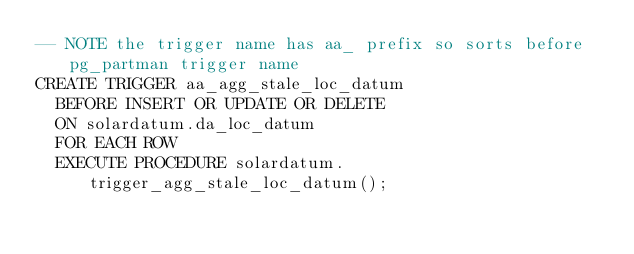Convert code to text. <code><loc_0><loc_0><loc_500><loc_500><_SQL_>-- NOTE the trigger name has aa_ prefix so sorts before pg_partman trigger name
CREATE TRIGGER aa_agg_stale_loc_datum
  BEFORE INSERT OR UPDATE OR DELETE
  ON solardatum.da_loc_datum
  FOR EACH ROW
  EXECUTE PROCEDURE solardatum.trigger_agg_stale_loc_datum();

</code> 